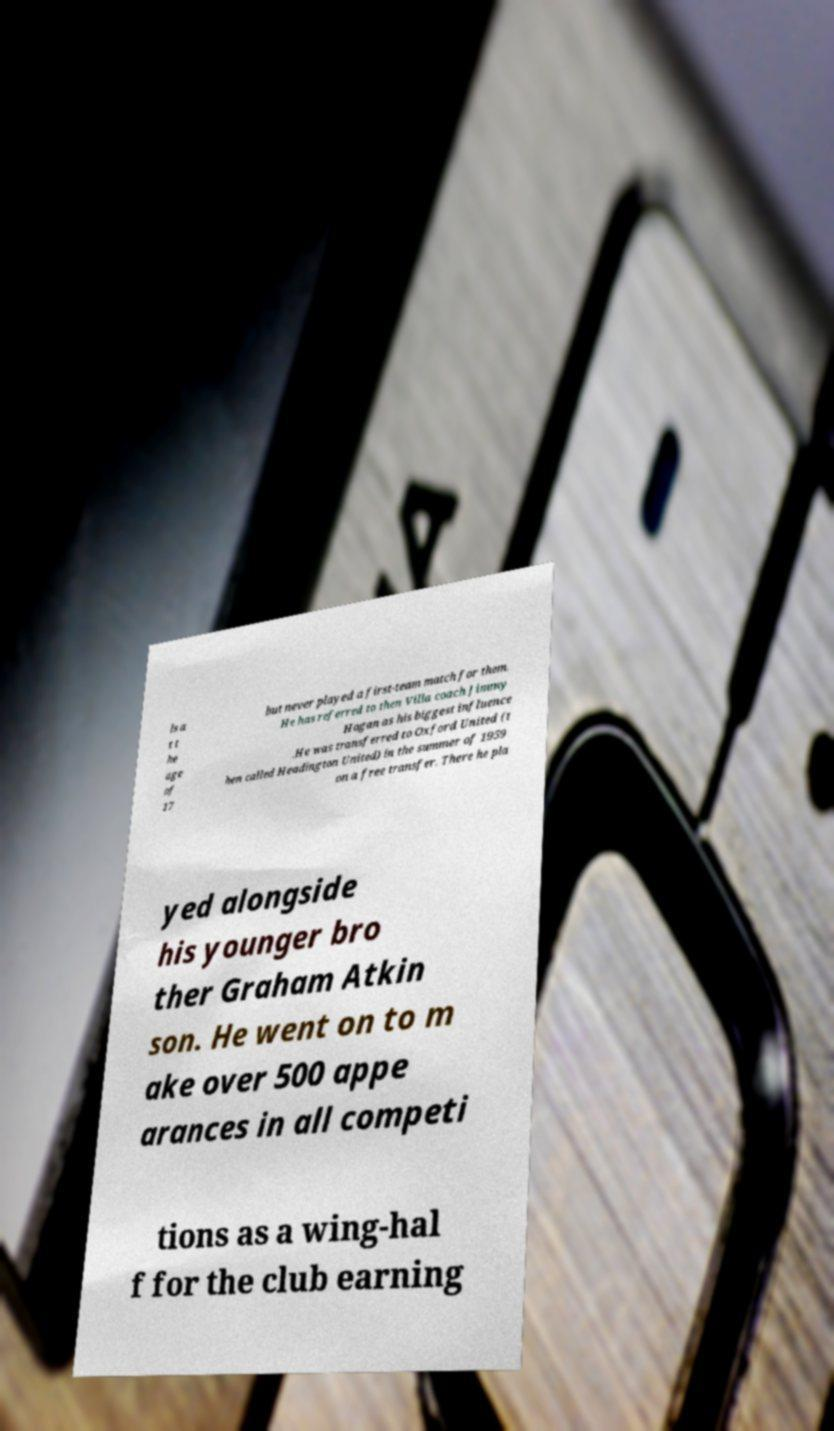Please read and relay the text visible in this image. What does it say? ls a t t he age of 17 but never played a first-team match for them. He has referred to then Villa coach Jimmy Hogan as his biggest influence .He was transferred to Oxford United (t hen called Headington United) in the summer of 1959 on a free transfer. There he pla yed alongside his younger bro ther Graham Atkin son. He went on to m ake over 500 appe arances in all competi tions as a wing-hal f for the club earning 